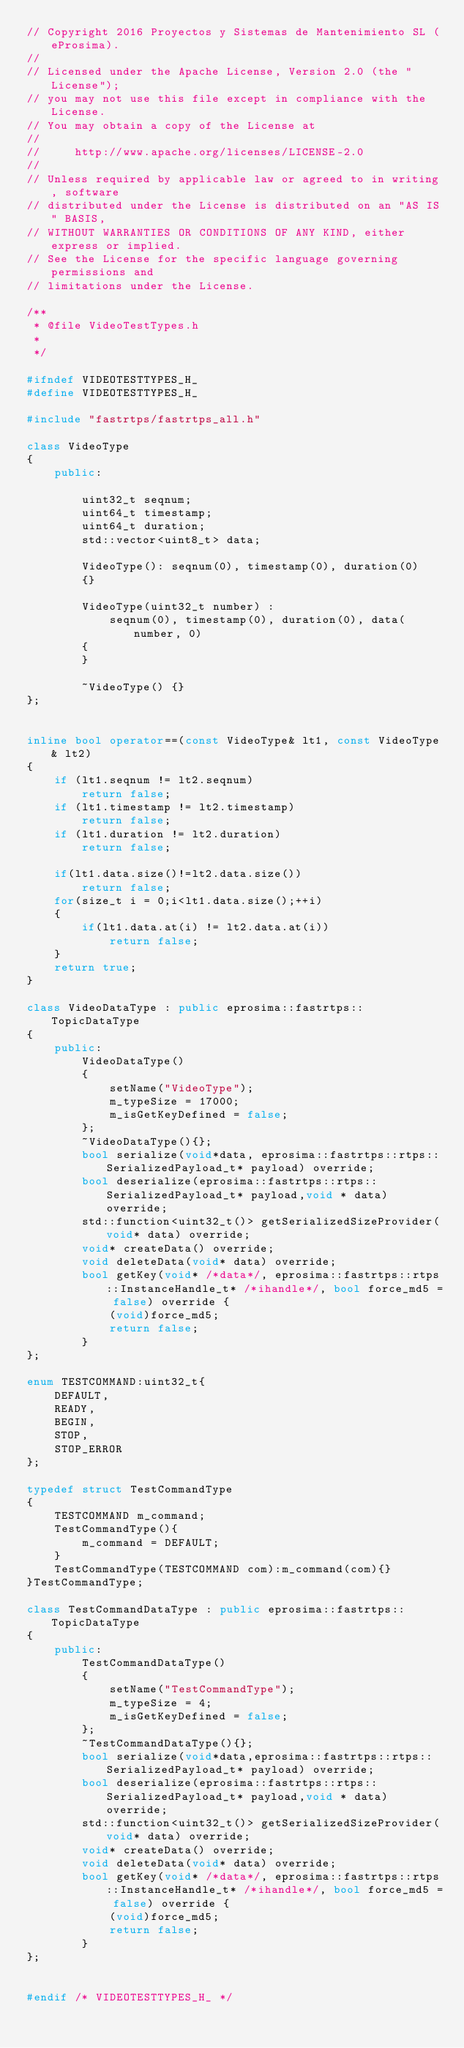Convert code to text. <code><loc_0><loc_0><loc_500><loc_500><_C++_>// Copyright 2016 Proyectos y Sistemas de Mantenimiento SL (eProsima).
//
// Licensed under the Apache License, Version 2.0 (the "License");
// you may not use this file except in compliance with the License.
// You may obtain a copy of the License at
//
//     http://www.apache.org/licenses/LICENSE-2.0
//
// Unless required by applicable law or agreed to in writing, software
// distributed under the License is distributed on an "AS IS" BASIS,
// WITHOUT WARRANTIES OR CONDITIONS OF ANY KIND, either express or implied.
// See the License for the specific language governing permissions and
// limitations under the License.

/**
 * @file VideoTestTypes.h
 *
 */

#ifndef VIDEOTESTTYPES_H_
#define VIDEOTESTTYPES_H_

#include "fastrtps/fastrtps_all.h"

class VideoType
{
    public:

        uint32_t seqnum;
        uint64_t timestamp;
        uint64_t duration;
        std::vector<uint8_t> data;

        VideoType(): seqnum(0), timestamp(0), duration(0)
        {}

        VideoType(uint32_t number) :
            seqnum(0), timestamp(0), duration(0), data(number, 0)
        {
        }

        ~VideoType() {}
};


inline bool operator==(const VideoType& lt1, const VideoType& lt2)
{
    if (lt1.seqnum != lt2.seqnum)
        return false;
    if (lt1.timestamp != lt2.timestamp)
        return false;
    if (lt1.duration != lt2.duration)
        return false;

    if(lt1.data.size()!=lt2.data.size())
        return false;
    for(size_t i = 0;i<lt1.data.size();++i)
    {
        if(lt1.data.at(i) != lt2.data.at(i))
            return false;
    }
    return true;
}

class VideoDataType : public eprosima::fastrtps::TopicDataType
{
    public:
        VideoDataType()
        {
            setName("VideoType");
            m_typeSize = 17000;
            m_isGetKeyDefined = false;
        };
        ~VideoDataType(){};
        bool serialize(void*data, eprosima::fastrtps::rtps::SerializedPayload_t* payload) override;
        bool deserialize(eprosima::fastrtps::rtps::SerializedPayload_t* payload,void * data) override;
        std::function<uint32_t()> getSerializedSizeProvider(void* data) override;
        void* createData() override;
        void deleteData(void* data) override;
        bool getKey(void* /*data*/, eprosima::fastrtps::rtps::InstanceHandle_t* /*ihandle*/, bool force_md5 = false) override {
            (void)force_md5;
            return false;
        }
};

enum TESTCOMMAND:uint32_t{
    DEFAULT,
    READY,
    BEGIN,
    STOP,
    STOP_ERROR
};

typedef struct TestCommandType
{
    TESTCOMMAND m_command;
    TestCommandType(){
        m_command = DEFAULT;
    }
    TestCommandType(TESTCOMMAND com):m_command(com){}
}TestCommandType;

class TestCommandDataType : public eprosima::fastrtps::TopicDataType
{
    public:
        TestCommandDataType()
        {
            setName("TestCommandType");
            m_typeSize = 4;
            m_isGetKeyDefined = false;
        };
        ~TestCommandDataType(){};
        bool serialize(void*data,eprosima::fastrtps::rtps::SerializedPayload_t* payload) override;
        bool deserialize(eprosima::fastrtps::rtps::SerializedPayload_t* payload,void * data) override;
        std::function<uint32_t()> getSerializedSizeProvider(void* data) override;
        void* createData() override;
        void deleteData(void* data) override;
        bool getKey(void* /*data*/, eprosima::fastrtps::rtps::InstanceHandle_t* /*ihandle*/, bool force_md5 = false) override {
            (void)force_md5;
            return false;
        }
};


#endif /* VIDEOTESTTYPES_H_ */
</code> 